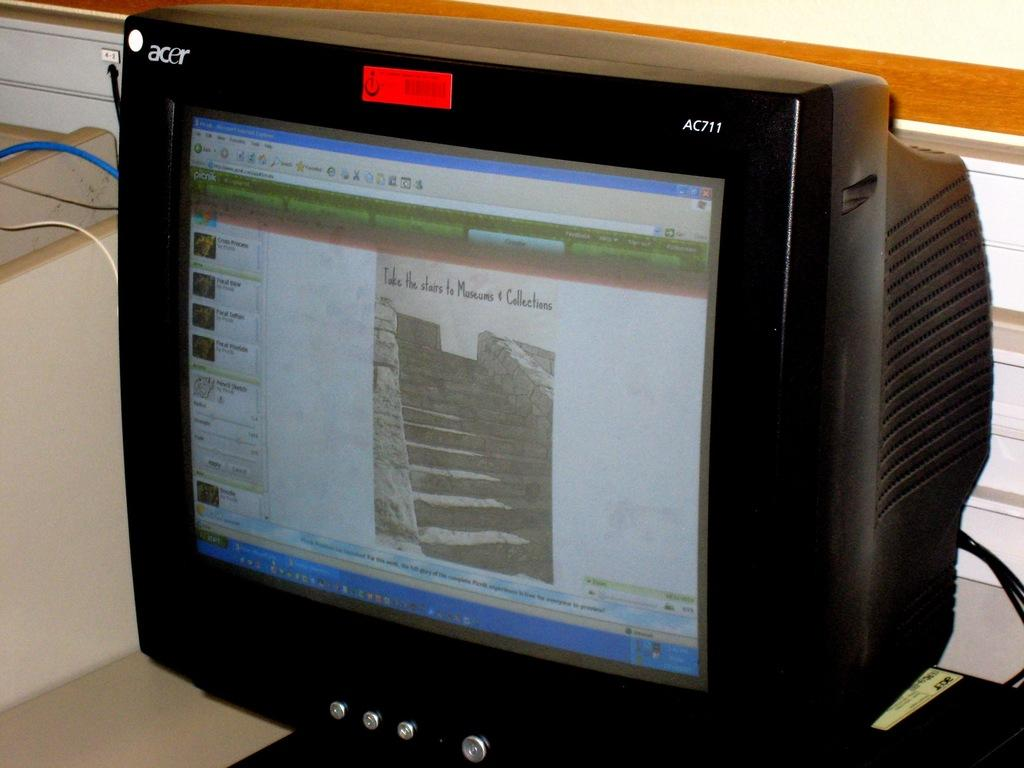<image>
Give a short and clear explanation of the subsequent image. An Acer AC711 computer monitor shows a picture on the screen for Take the Stairs to Museums and Collections. 